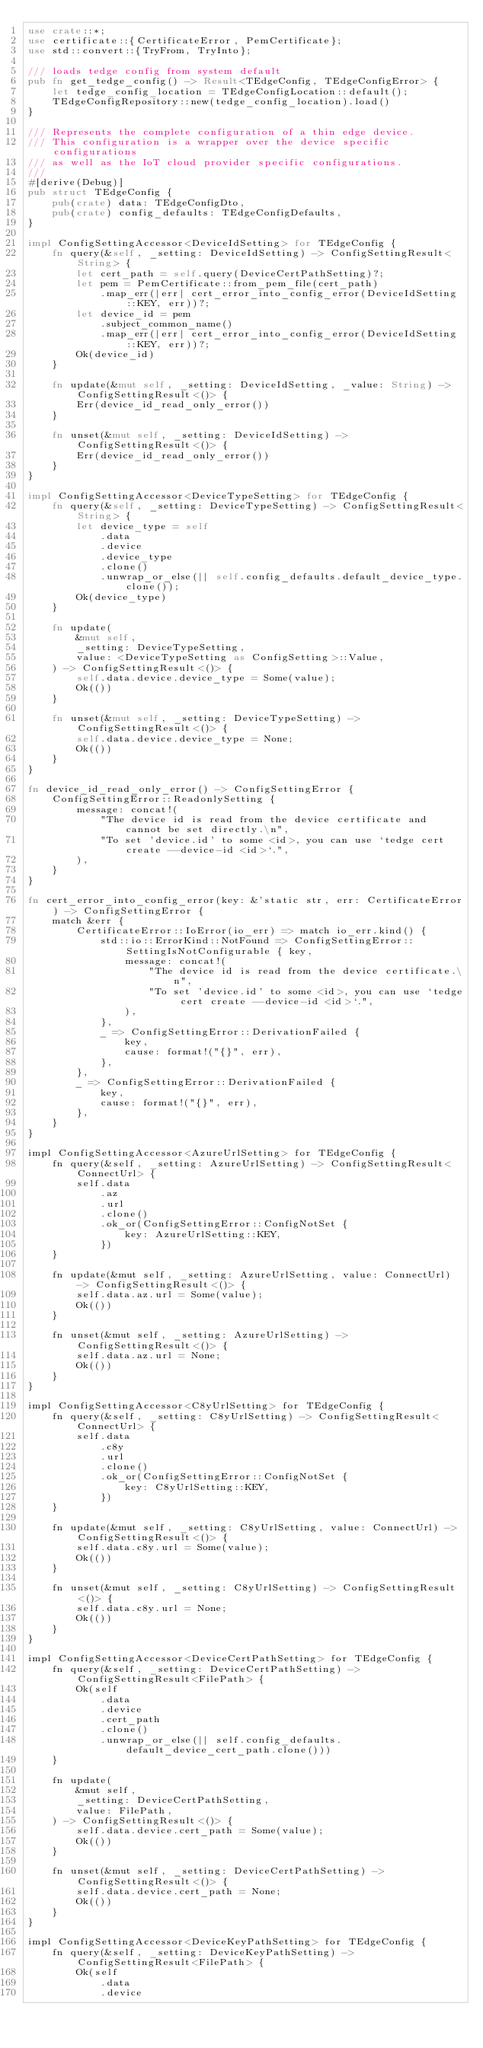<code> <loc_0><loc_0><loc_500><loc_500><_Rust_>use crate::*;
use certificate::{CertificateError, PemCertificate};
use std::convert::{TryFrom, TryInto};

/// loads tedge config from system default
pub fn get_tedge_config() -> Result<TEdgeConfig, TEdgeConfigError> {
    let tedge_config_location = TEdgeConfigLocation::default();
    TEdgeConfigRepository::new(tedge_config_location).load()
}

/// Represents the complete configuration of a thin edge device.
/// This configuration is a wrapper over the device specific configurations
/// as well as the IoT cloud provider specific configurations.
///
#[derive(Debug)]
pub struct TEdgeConfig {
    pub(crate) data: TEdgeConfigDto,
    pub(crate) config_defaults: TEdgeConfigDefaults,
}

impl ConfigSettingAccessor<DeviceIdSetting> for TEdgeConfig {
    fn query(&self, _setting: DeviceIdSetting) -> ConfigSettingResult<String> {
        let cert_path = self.query(DeviceCertPathSetting)?;
        let pem = PemCertificate::from_pem_file(cert_path)
            .map_err(|err| cert_error_into_config_error(DeviceIdSetting::KEY, err))?;
        let device_id = pem
            .subject_common_name()
            .map_err(|err| cert_error_into_config_error(DeviceIdSetting::KEY, err))?;
        Ok(device_id)
    }

    fn update(&mut self, _setting: DeviceIdSetting, _value: String) -> ConfigSettingResult<()> {
        Err(device_id_read_only_error())
    }

    fn unset(&mut self, _setting: DeviceIdSetting) -> ConfigSettingResult<()> {
        Err(device_id_read_only_error())
    }
}

impl ConfigSettingAccessor<DeviceTypeSetting> for TEdgeConfig {
    fn query(&self, _setting: DeviceTypeSetting) -> ConfigSettingResult<String> {
        let device_type = self
            .data
            .device
            .device_type
            .clone()
            .unwrap_or_else(|| self.config_defaults.default_device_type.clone());
        Ok(device_type)
    }

    fn update(
        &mut self,
        _setting: DeviceTypeSetting,
        value: <DeviceTypeSetting as ConfigSetting>::Value,
    ) -> ConfigSettingResult<()> {
        self.data.device.device_type = Some(value);
        Ok(())
    }

    fn unset(&mut self, _setting: DeviceTypeSetting) -> ConfigSettingResult<()> {
        self.data.device.device_type = None;
        Ok(())
    }
}

fn device_id_read_only_error() -> ConfigSettingError {
    ConfigSettingError::ReadonlySetting {
        message: concat!(
            "The device id is read from the device certificate and cannot be set directly.\n",
            "To set 'device.id' to some <id>, you can use `tedge cert create --device-id <id>`.",
        ),
    }
}

fn cert_error_into_config_error(key: &'static str, err: CertificateError) -> ConfigSettingError {
    match &err {
        CertificateError::IoError(io_err) => match io_err.kind() {
            std::io::ErrorKind::NotFound => ConfigSettingError::SettingIsNotConfigurable { key,
                message: concat!(
                    "The device id is read from the device certificate.\n",
                    "To set 'device.id' to some <id>, you can use `tedge cert create --device-id <id>`.",
                ),
            },
            _ => ConfigSettingError::DerivationFailed {
                key,
                cause: format!("{}", err),
            },
        },
        _ => ConfigSettingError::DerivationFailed {
            key,
            cause: format!("{}", err),
        },
    }
}

impl ConfigSettingAccessor<AzureUrlSetting> for TEdgeConfig {
    fn query(&self, _setting: AzureUrlSetting) -> ConfigSettingResult<ConnectUrl> {
        self.data
            .az
            .url
            .clone()
            .ok_or(ConfigSettingError::ConfigNotSet {
                key: AzureUrlSetting::KEY,
            })
    }

    fn update(&mut self, _setting: AzureUrlSetting, value: ConnectUrl) -> ConfigSettingResult<()> {
        self.data.az.url = Some(value);
        Ok(())
    }

    fn unset(&mut self, _setting: AzureUrlSetting) -> ConfigSettingResult<()> {
        self.data.az.url = None;
        Ok(())
    }
}

impl ConfigSettingAccessor<C8yUrlSetting> for TEdgeConfig {
    fn query(&self, _setting: C8yUrlSetting) -> ConfigSettingResult<ConnectUrl> {
        self.data
            .c8y
            .url
            .clone()
            .ok_or(ConfigSettingError::ConfigNotSet {
                key: C8yUrlSetting::KEY,
            })
    }

    fn update(&mut self, _setting: C8yUrlSetting, value: ConnectUrl) -> ConfigSettingResult<()> {
        self.data.c8y.url = Some(value);
        Ok(())
    }

    fn unset(&mut self, _setting: C8yUrlSetting) -> ConfigSettingResult<()> {
        self.data.c8y.url = None;
        Ok(())
    }
}

impl ConfigSettingAccessor<DeviceCertPathSetting> for TEdgeConfig {
    fn query(&self, _setting: DeviceCertPathSetting) -> ConfigSettingResult<FilePath> {
        Ok(self
            .data
            .device
            .cert_path
            .clone()
            .unwrap_or_else(|| self.config_defaults.default_device_cert_path.clone()))
    }

    fn update(
        &mut self,
        _setting: DeviceCertPathSetting,
        value: FilePath,
    ) -> ConfigSettingResult<()> {
        self.data.device.cert_path = Some(value);
        Ok(())
    }

    fn unset(&mut self, _setting: DeviceCertPathSetting) -> ConfigSettingResult<()> {
        self.data.device.cert_path = None;
        Ok(())
    }
}

impl ConfigSettingAccessor<DeviceKeyPathSetting> for TEdgeConfig {
    fn query(&self, _setting: DeviceKeyPathSetting) -> ConfigSettingResult<FilePath> {
        Ok(self
            .data
            .device</code> 